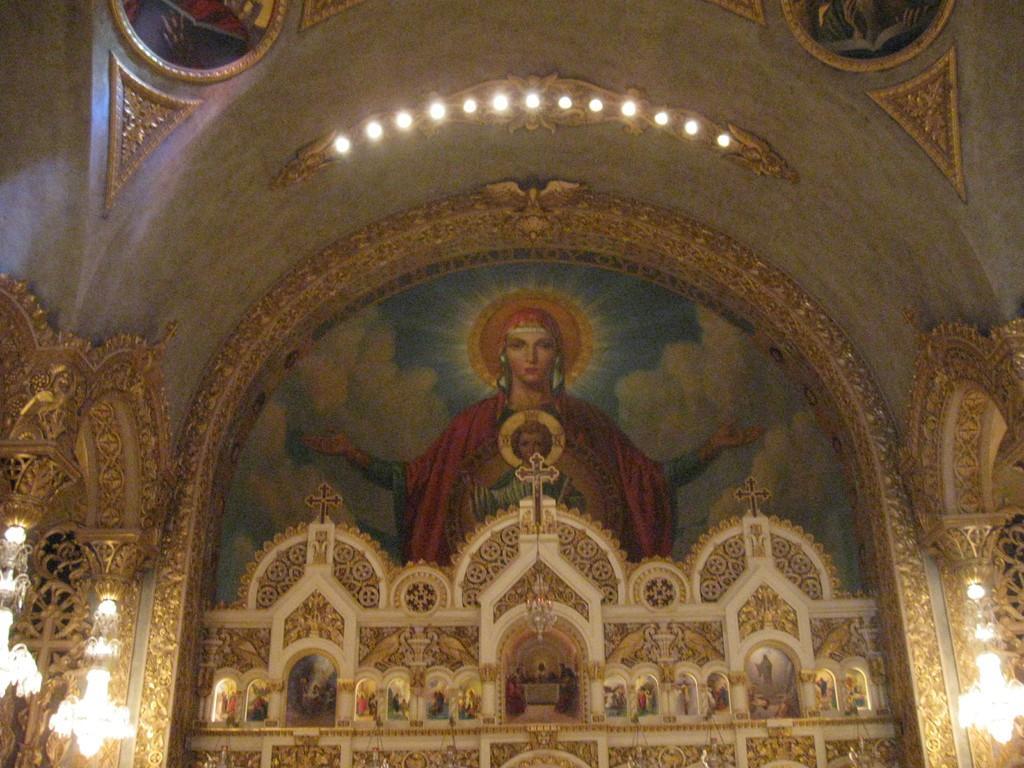Describe this image in one or two sentences. This image is taken inside the building. In the center of the image there is a wall painting. At the bottom we can see an alter and there are lights. We can see chandeliers. 